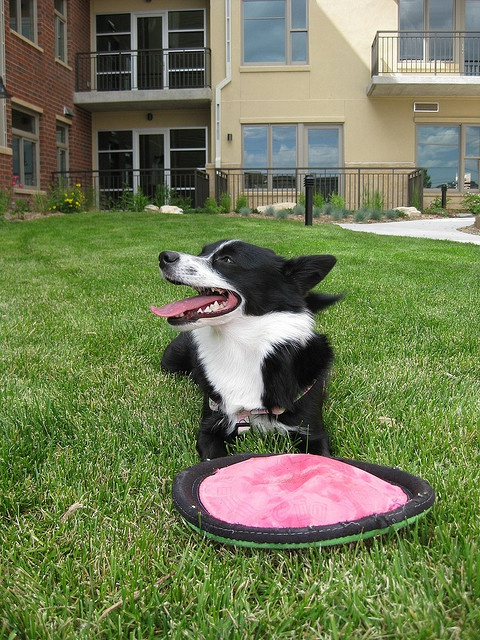Describe the objects in this image and their specific colors. I can see dog in gray, black, lightgray, and darkgray tones and frisbee in gray, lightpink, and black tones in this image. 